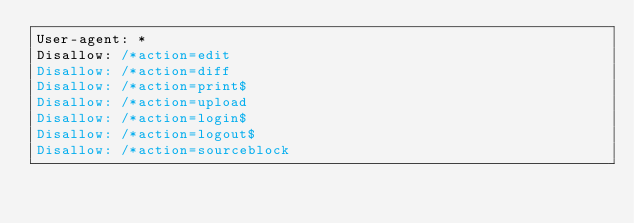Convert code to text. <code><loc_0><loc_0><loc_500><loc_500><_C++_>User-agent: *
Disallow: /*action=edit
Disallow: /*action=diff
Disallow: /*action=print$
Disallow: /*action=upload
Disallow: /*action=login$
Disallow: /*action=logout$
Disallow: /*action=sourceblock
</code> 